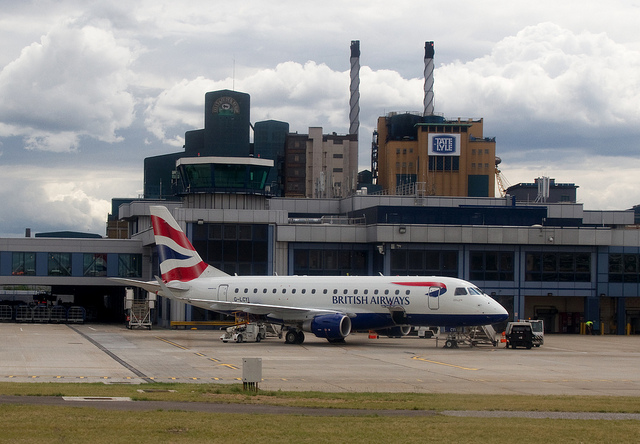Can you tell what time of day it might be? Based on the lighting and shadows visible in the image, it seems to be daytime, but the specific time cannot be determined precisely without more context. 